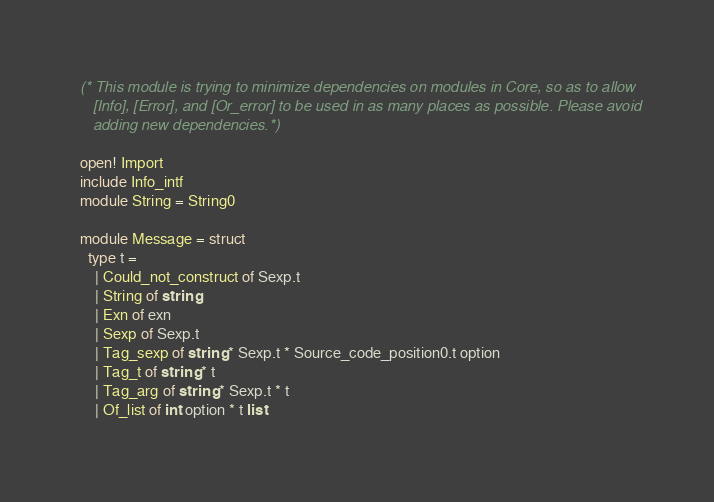<code> <loc_0><loc_0><loc_500><loc_500><_OCaml_>(* This module is trying to minimize dependencies on modules in Core, so as to allow
   [Info], [Error], and [Or_error] to be used in as many places as possible. Please avoid
   adding new dependencies. *)

open! Import
include Info_intf
module String = String0

module Message = struct
  type t =
    | Could_not_construct of Sexp.t
    | String of string
    | Exn of exn
    | Sexp of Sexp.t
    | Tag_sexp of string * Sexp.t * Source_code_position0.t option
    | Tag_t of string * t
    | Tag_arg of string * Sexp.t * t
    | Of_list of int option * t list</code> 